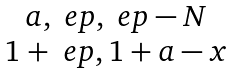Convert formula to latex. <formula><loc_0><loc_0><loc_500><loc_500>\begin{matrix} { a , \ e p , \ e p - N } \\ { 1 + \ e p , 1 + a - x } \end{matrix}</formula> 